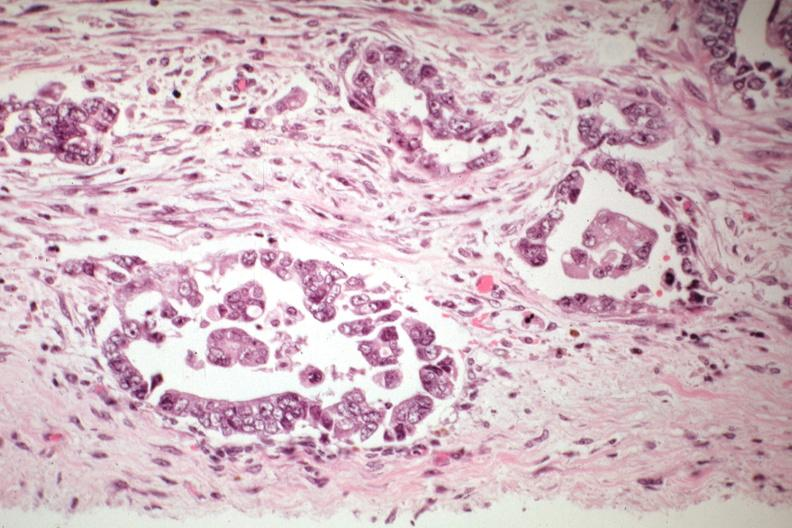what is present?
Answer the question using a single word or phrase. Uterus 